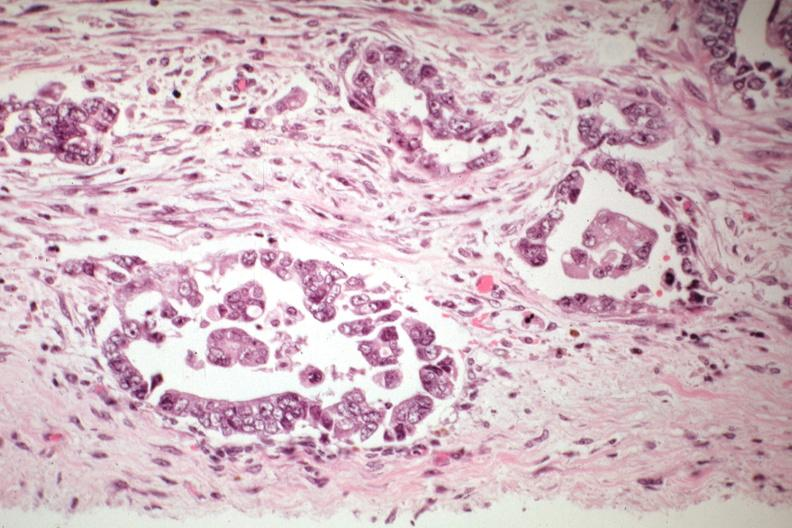what is present?
Answer the question using a single word or phrase. Uterus 